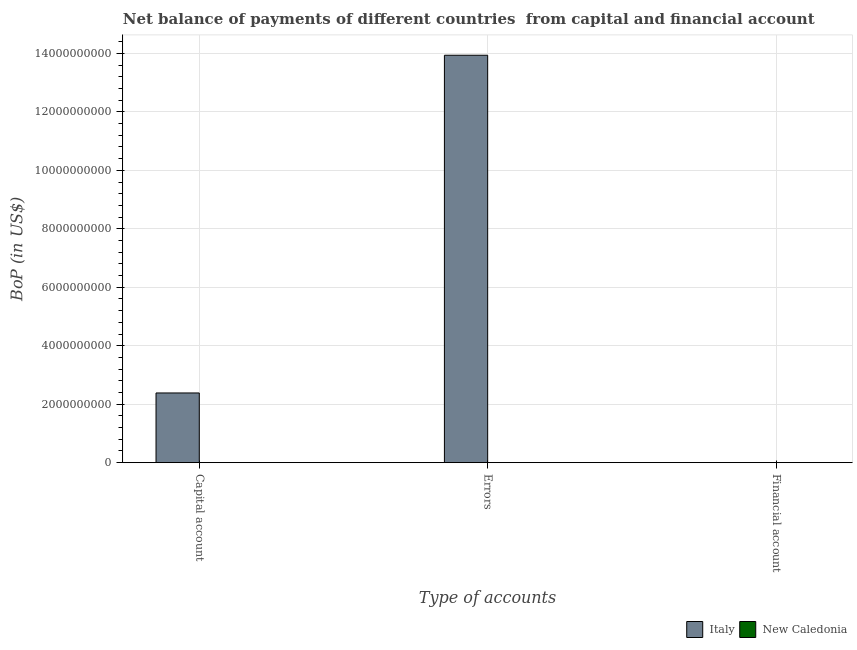What is the label of the 2nd group of bars from the left?
Your response must be concise. Errors. What is the amount of financial account in Italy?
Your answer should be compact. 0. Across all countries, what is the maximum amount of errors?
Give a very brief answer. 1.39e+1. Across all countries, what is the minimum amount of net capital account?
Provide a succinct answer. 3.86e+06. What is the total amount of errors in the graph?
Your response must be concise. 1.39e+1. What is the difference between the amount of net capital account in New Caledonia and that in Italy?
Make the answer very short. -2.38e+09. What is the difference between the amount of net capital account in Italy and the amount of financial account in New Caledonia?
Offer a terse response. 2.38e+09. What is the average amount of errors per country?
Keep it short and to the point. 6.97e+09. In how many countries, is the amount of errors greater than 11600000000 US$?
Give a very brief answer. 1. What is the ratio of the amount of net capital account in Italy to that in New Caledonia?
Your response must be concise. 618.11. Is the amount of net capital account in Italy less than that in New Caledonia?
Give a very brief answer. No. What is the difference between the highest and the second highest amount of net capital account?
Your answer should be compact. 2.38e+09. What is the difference between the highest and the lowest amount of net capital account?
Provide a short and direct response. 2.38e+09. Is the sum of the amount of net capital account in Italy and New Caledonia greater than the maximum amount of financial account across all countries?
Your answer should be compact. Yes. How many countries are there in the graph?
Your answer should be very brief. 2. Does the graph contain grids?
Your answer should be very brief. Yes. Where does the legend appear in the graph?
Your answer should be compact. Bottom right. What is the title of the graph?
Make the answer very short. Net balance of payments of different countries  from capital and financial account. What is the label or title of the X-axis?
Keep it short and to the point. Type of accounts. What is the label or title of the Y-axis?
Provide a succinct answer. BoP (in US$). What is the BoP (in US$) in Italy in Capital account?
Offer a very short reply. 2.38e+09. What is the BoP (in US$) in New Caledonia in Capital account?
Your answer should be compact. 3.86e+06. What is the BoP (in US$) in Italy in Errors?
Provide a succinct answer. 1.39e+1. What is the BoP (in US$) of New Caledonia in Errors?
Provide a short and direct response. 0. Across all Type of accounts, what is the maximum BoP (in US$) of Italy?
Give a very brief answer. 1.39e+1. Across all Type of accounts, what is the maximum BoP (in US$) of New Caledonia?
Your response must be concise. 3.86e+06. Across all Type of accounts, what is the minimum BoP (in US$) of Italy?
Provide a succinct answer. 0. What is the total BoP (in US$) of Italy in the graph?
Your response must be concise. 1.63e+1. What is the total BoP (in US$) in New Caledonia in the graph?
Your response must be concise. 3.86e+06. What is the difference between the BoP (in US$) of Italy in Capital account and that in Errors?
Keep it short and to the point. -1.16e+1. What is the average BoP (in US$) of Italy per Type of accounts?
Ensure brevity in your answer.  5.44e+09. What is the average BoP (in US$) of New Caledonia per Type of accounts?
Offer a terse response. 1.29e+06. What is the difference between the BoP (in US$) in Italy and BoP (in US$) in New Caledonia in Capital account?
Your response must be concise. 2.38e+09. What is the ratio of the BoP (in US$) of Italy in Capital account to that in Errors?
Your response must be concise. 0.17. What is the difference between the highest and the lowest BoP (in US$) of Italy?
Offer a very short reply. 1.39e+1. What is the difference between the highest and the lowest BoP (in US$) in New Caledonia?
Ensure brevity in your answer.  3.86e+06. 